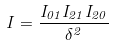<formula> <loc_0><loc_0><loc_500><loc_500>I = \frac { I _ { 0 1 } I _ { 2 1 } I _ { 2 0 } } { \delta ^ { 2 } }</formula> 